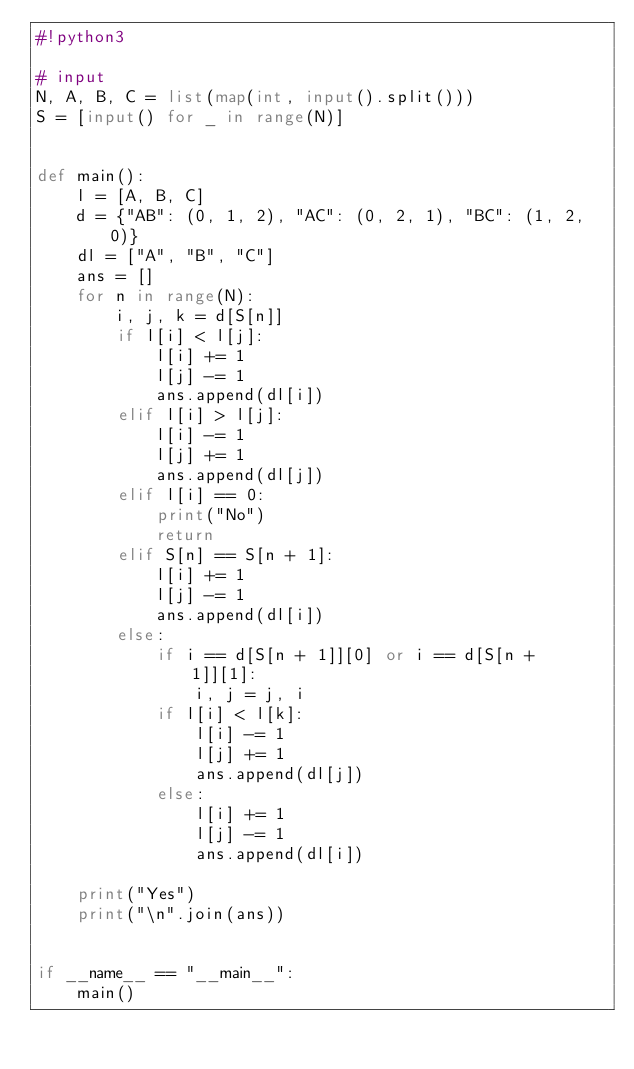Convert code to text. <code><loc_0><loc_0><loc_500><loc_500><_Python_>#!python3

# input
N, A, B, C = list(map(int, input().split()))
S = [input() for _ in range(N)]


def main():
    l = [A, B, C]
    d = {"AB": (0, 1, 2), "AC": (0, 2, 1), "BC": (1, 2, 0)}
    dl = ["A", "B", "C"]
    ans = []
    for n in range(N):
        i, j, k = d[S[n]]
        if l[i] < l[j]:
            l[i] += 1
            l[j] -= 1
            ans.append(dl[i])
        elif l[i] > l[j]:
            l[i] -= 1
            l[j] += 1
            ans.append(dl[j])
        elif l[i] == 0:
            print("No")
            return
        elif S[n] == S[n + 1]:
            l[i] += 1
            l[j] -= 1
            ans.append(dl[i])
        else:
            if i == d[S[n + 1]][0] or i == d[S[n + 1]][1]:
                i, j = j, i
            if l[i] < l[k]:
                l[i] -= 1
                l[j] += 1
                ans.append(dl[j])
            else:
                l[i] += 1
                l[j] -= 1
                ans.append(dl[i])
        
    print("Yes")
    print("\n".join(ans))


if __name__ == "__main__":
    main()
</code> 